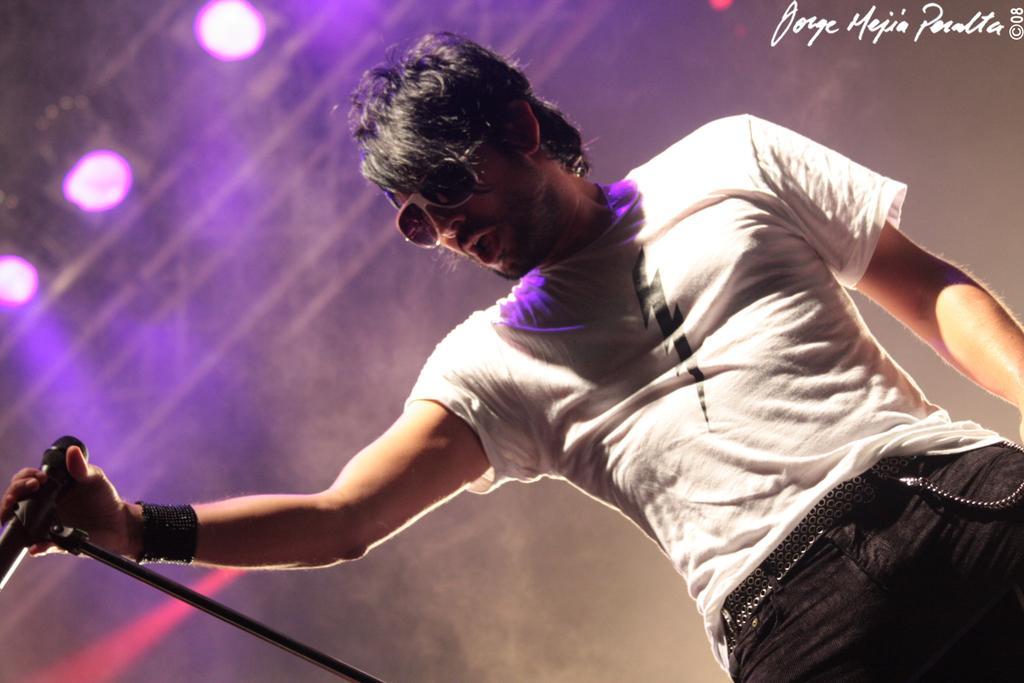Could you give a brief overview of what you see in this image? In this picture there is a person with white t-shirt is standing and singing and he is holding the microphone. At the top there are lights. In the top right there is a text. 